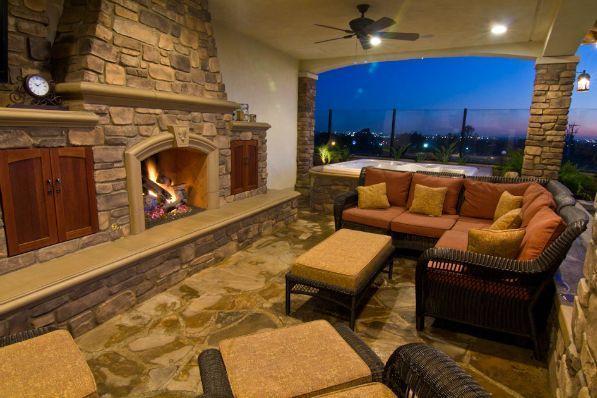How many people are in the room?
Give a very brief answer. 0. How many pillows do you see?
Give a very brief answer. 5. 